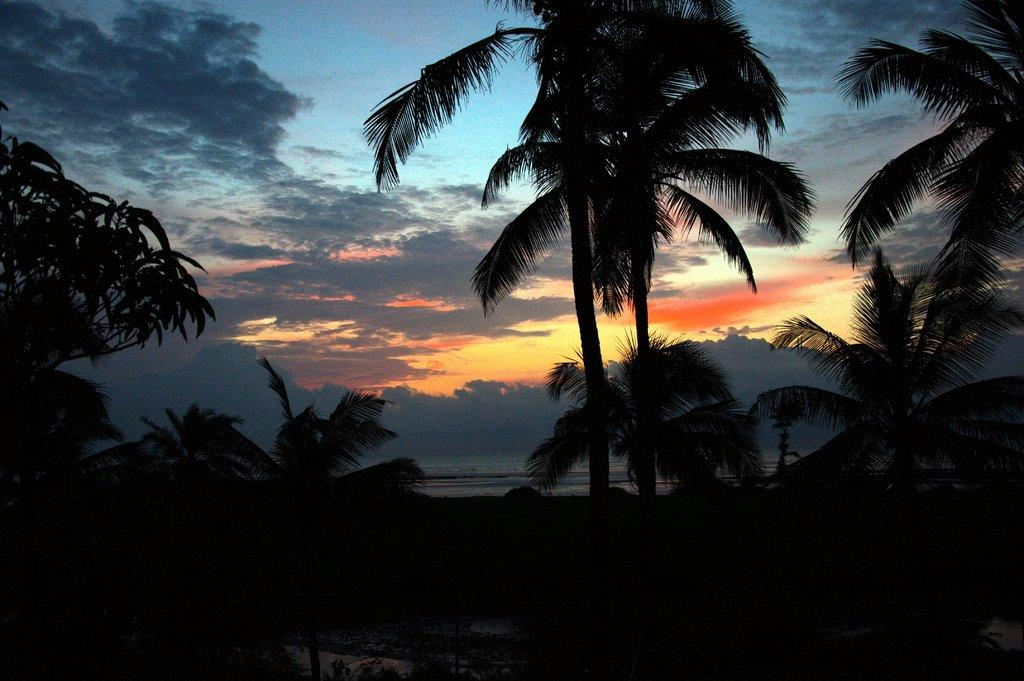What type of vegetation can be seen in the image? There are trees in the image. What can be seen in the sky in the image? There are clouds in the image. How many deer are visible in the image? There are no deer present in the image. What type of beast can be seen interacting with the trees in the image? There is no beast present in the image; only trees and clouds are visible. 